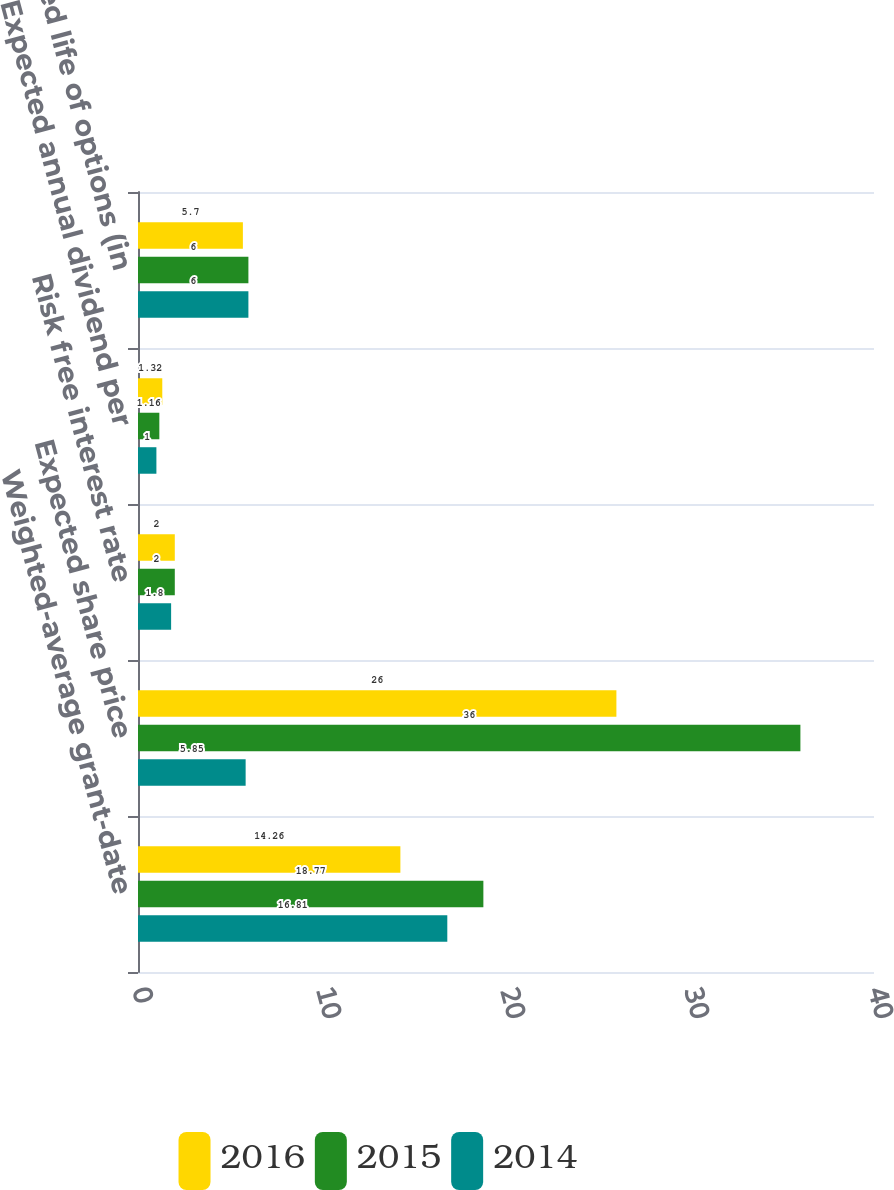Convert chart. <chart><loc_0><loc_0><loc_500><loc_500><stacked_bar_chart><ecel><fcel>Weighted-average grant-date<fcel>Expected share price<fcel>Risk free interest rate<fcel>Expected annual dividend per<fcel>Expected life of options (in<nl><fcel>2016<fcel>14.26<fcel>26<fcel>2<fcel>1.32<fcel>5.7<nl><fcel>2015<fcel>18.77<fcel>36<fcel>2<fcel>1.16<fcel>6<nl><fcel>2014<fcel>16.81<fcel>5.85<fcel>1.8<fcel>1<fcel>6<nl></chart> 